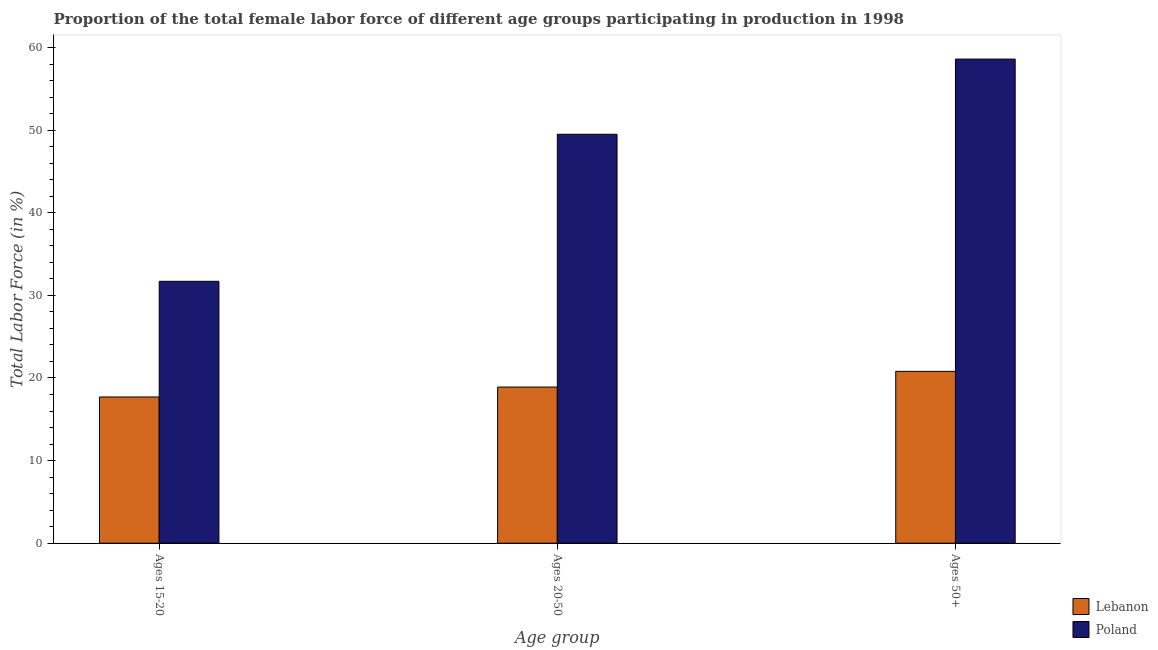Are the number of bars on each tick of the X-axis equal?
Your answer should be very brief. Yes. How many bars are there on the 2nd tick from the right?
Offer a very short reply. 2. What is the label of the 1st group of bars from the left?
Provide a succinct answer. Ages 15-20. What is the percentage of female labor force above age 50 in Lebanon?
Provide a succinct answer. 20.8. Across all countries, what is the maximum percentage of female labor force within the age group 15-20?
Offer a terse response. 31.7. Across all countries, what is the minimum percentage of female labor force within the age group 20-50?
Your answer should be very brief. 18.9. In which country was the percentage of female labor force above age 50 maximum?
Provide a succinct answer. Poland. In which country was the percentage of female labor force within the age group 20-50 minimum?
Your answer should be very brief. Lebanon. What is the total percentage of female labor force within the age group 15-20 in the graph?
Offer a terse response. 49.4. What is the difference between the percentage of female labor force within the age group 20-50 in Poland and that in Lebanon?
Your response must be concise. 30.6. What is the difference between the percentage of female labor force above age 50 in Poland and the percentage of female labor force within the age group 20-50 in Lebanon?
Make the answer very short. 39.7. What is the average percentage of female labor force within the age group 20-50 per country?
Ensure brevity in your answer.  34.2. What is the difference between the percentage of female labor force within the age group 15-20 and percentage of female labor force above age 50 in Lebanon?
Your answer should be compact. -3.1. In how many countries, is the percentage of female labor force within the age group 20-50 greater than 12 %?
Offer a terse response. 2. What is the ratio of the percentage of female labor force above age 50 in Poland to that in Lebanon?
Provide a succinct answer. 2.82. What is the difference between the highest and the second highest percentage of female labor force within the age group 20-50?
Offer a terse response. 30.6. What is the difference between the highest and the lowest percentage of female labor force within the age group 20-50?
Provide a succinct answer. 30.6. Is the sum of the percentage of female labor force within the age group 20-50 in Lebanon and Poland greater than the maximum percentage of female labor force within the age group 15-20 across all countries?
Provide a short and direct response. Yes. What does the 2nd bar from the left in Ages 15-20 represents?
Provide a succinct answer. Poland. Is it the case that in every country, the sum of the percentage of female labor force within the age group 15-20 and percentage of female labor force within the age group 20-50 is greater than the percentage of female labor force above age 50?
Offer a terse response. Yes. How many countries are there in the graph?
Your answer should be compact. 2. What is the difference between two consecutive major ticks on the Y-axis?
Your answer should be very brief. 10. Are the values on the major ticks of Y-axis written in scientific E-notation?
Keep it short and to the point. No. Does the graph contain any zero values?
Give a very brief answer. No. Where does the legend appear in the graph?
Ensure brevity in your answer.  Bottom right. What is the title of the graph?
Offer a very short reply. Proportion of the total female labor force of different age groups participating in production in 1998. Does "Lao PDR" appear as one of the legend labels in the graph?
Offer a very short reply. No. What is the label or title of the X-axis?
Keep it short and to the point. Age group. What is the label or title of the Y-axis?
Provide a short and direct response. Total Labor Force (in %). What is the Total Labor Force (in %) of Lebanon in Ages 15-20?
Offer a very short reply. 17.7. What is the Total Labor Force (in %) of Poland in Ages 15-20?
Your answer should be very brief. 31.7. What is the Total Labor Force (in %) in Lebanon in Ages 20-50?
Give a very brief answer. 18.9. What is the Total Labor Force (in %) of Poland in Ages 20-50?
Offer a very short reply. 49.5. What is the Total Labor Force (in %) in Lebanon in Ages 50+?
Your answer should be compact. 20.8. What is the Total Labor Force (in %) in Poland in Ages 50+?
Ensure brevity in your answer.  58.6. Across all Age group, what is the maximum Total Labor Force (in %) of Lebanon?
Your response must be concise. 20.8. Across all Age group, what is the maximum Total Labor Force (in %) of Poland?
Give a very brief answer. 58.6. Across all Age group, what is the minimum Total Labor Force (in %) in Lebanon?
Keep it short and to the point. 17.7. Across all Age group, what is the minimum Total Labor Force (in %) of Poland?
Your answer should be very brief. 31.7. What is the total Total Labor Force (in %) of Lebanon in the graph?
Offer a terse response. 57.4. What is the total Total Labor Force (in %) in Poland in the graph?
Provide a succinct answer. 139.8. What is the difference between the Total Labor Force (in %) of Lebanon in Ages 15-20 and that in Ages 20-50?
Your response must be concise. -1.2. What is the difference between the Total Labor Force (in %) in Poland in Ages 15-20 and that in Ages 20-50?
Give a very brief answer. -17.8. What is the difference between the Total Labor Force (in %) in Poland in Ages 15-20 and that in Ages 50+?
Your answer should be very brief. -26.9. What is the difference between the Total Labor Force (in %) in Lebanon in Ages 15-20 and the Total Labor Force (in %) in Poland in Ages 20-50?
Make the answer very short. -31.8. What is the difference between the Total Labor Force (in %) of Lebanon in Ages 15-20 and the Total Labor Force (in %) of Poland in Ages 50+?
Provide a short and direct response. -40.9. What is the difference between the Total Labor Force (in %) in Lebanon in Ages 20-50 and the Total Labor Force (in %) in Poland in Ages 50+?
Offer a very short reply. -39.7. What is the average Total Labor Force (in %) of Lebanon per Age group?
Make the answer very short. 19.13. What is the average Total Labor Force (in %) of Poland per Age group?
Keep it short and to the point. 46.6. What is the difference between the Total Labor Force (in %) of Lebanon and Total Labor Force (in %) of Poland in Ages 15-20?
Your answer should be compact. -14. What is the difference between the Total Labor Force (in %) in Lebanon and Total Labor Force (in %) in Poland in Ages 20-50?
Make the answer very short. -30.6. What is the difference between the Total Labor Force (in %) of Lebanon and Total Labor Force (in %) of Poland in Ages 50+?
Make the answer very short. -37.8. What is the ratio of the Total Labor Force (in %) of Lebanon in Ages 15-20 to that in Ages 20-50?
Provide a succinct answer. 0.94. What is the ratio of the Total Labor Force (in %) in Poland in Ages 15-20 to that in Ages 20-50?
Provide a succinct answer. 0.64. What is the ratio of the Total Labor Force (in %) of Lebanon in Ages 15-20 to that in Ages 50+?
Offer a terse response. 0.85. What is the ratio of the Total Labor Force (in %) in Poland in Ages 15-20 to that in Ages 50+?
Keep it short and to the point. 0.54. What is the ratio of the Total Labor Force (in %) of Lebanon in Ages 20-50 to that in Ages 50+?
Give a very brief answer. 0.91. What is the ratio of the Total Labor Force (in %) in Poland in Ages 20-50 to that in Ages 50+?
Offer a very short reply. 0.84. What is the difference between the highest and the lowest Total Labor Force (in %) of Lebanon?
Your response must be concise. 3.1. What is the difference between the highest and the lowest Total Labor Force (in %) of Poland?
Your answer should be very brief. 26.9. 